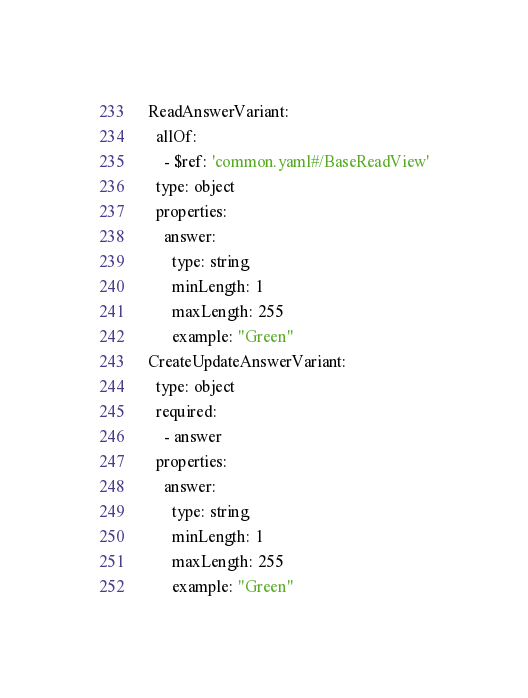<code> <loc_0><loc_0><loc_500><loc_500><_YAML_>ReadAnswerVariant:
  allOf:
    - $ref: 'common.yaml#/BaseReadView'
  type: object
  properties:
    answer:
      type: string
      minLength: 1
      maxLength: 255
      example: "Green"
CreateUpdateAnswerVariant:
  type: object
  required:
    - answer
  properties:
    answer:
      type: string
      minLength: 1
      maxLength: 255
      example: "Green"
</code> 